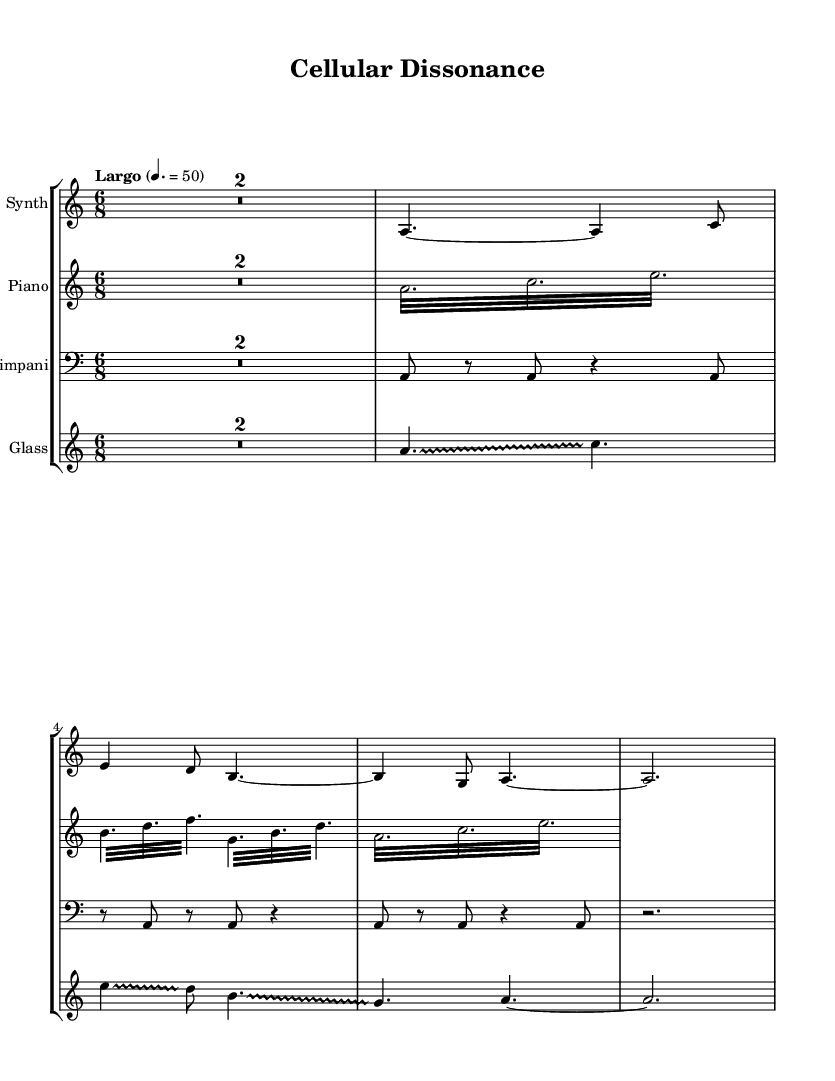What is the key signature of this music? The key signature is A minor, which features no sharps and is the relative minor of C major. This can be identified from the absence of sharps or flats.
Answer: A minor What is the time signature of this music? The time signature is 6/8, which indicates there are six eighth notes per measure. This can be seen at the beginning of the score where the time signature is marked.
Answer: 6/8 What is the tempo marking of this music? The tempo marking is "Largo," which is indicated at the start of the score. Largo typically suggests a slow pace, and the specific metronome marking of 50 beats per minute further defines this tempo.
Answer: Largo How many instruments are notated in the score? There are four instruments notated in the score: Synth, Piano, Timpani, and Glass. This information is presented in the staff group at the beginning of the score where each instrument's name is labeled.
Answer: Four Describe the rhythm pattern used in the 'Piano' section. The 'Piano' section predominantly features tremolo notes, specifically using rapid repeated notes. The measures contain short notes (thirty-seconds) to create a fluid, ambient texture that mimics the complexities of cellular processes. The alternation between these rapid notes and their structure contributes to an organic rhythmic flow reminiscent of chemical reactions.
Answer: Tremolo What unique effect is used in the 'Glass' section? The unique effect used in the 'Glass' section is glissando, which is a sliding motion between notes. This is indicated by the glissando markings adjacent to several notes in this part, creating a fluid transition that enhances the ambient soundscape.
Answer: Glissando Which instrument primarily carries the melodic line in this sheet music? The melodic line is primarily carried by the Synth. It features sustained notes and a melody that unfolds with space, presenting a soothing and abstract thematic line that complements the ambient character.
Answer: Synth 